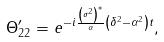<formula> <loc_0><loc_0><loc_500><loc_500>\Theta _ { 2 2 } ^ { \prime } = e ^ { - i \frac { \left ( \sigma ^ { 2 } \right ) ^ { * } } \alpha \left ( \delta ^ { 2 } - \alpha ^ { 2 } \right ) t } ,</formula> 